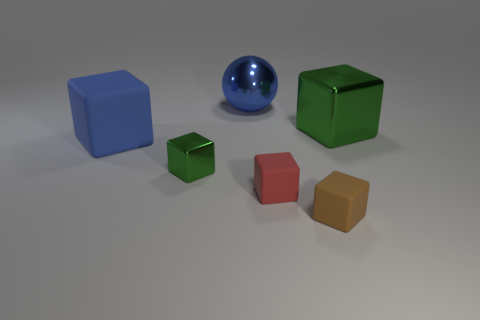Are there any objects that seem to be unique compared to the others? Each object holds unique properties, but the small green block in the foreground stands out as it appears to have a different texture — matte, as opposed to the shiny or reflective surfaces of the nearby objects. Furthermore, its smaller size compared to the other blocks suggests it might serve a specific, perhaps distinctive, function if we imagine these objects as part of a larger set. In what way does it seem unique? The uniqueness stems from its matte finish, which contrasts sharply with the lustrous sheen of the other objects, suggesting a potential difference in material or purpose. Additionally, the smaller scale of this green block may imply it is part of a finer, perhaps more intricate or delicate, construction within a hypothetical scenario. 